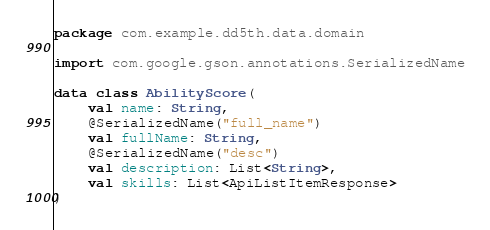<code> <loc_0><loc_0><loc_500><loc_500><_Kotlin_>package com.example.dd5th.data.domain

import com.google.gson.annotations.SerializedName

data class AbilityScore(
    val name: String,
    @SerializedName("full_name")
    val fullName: String,
    @SerializedName("desc")
    val description: List<String>,
    val skills: List<ApiListItemResponse>
)</code> 